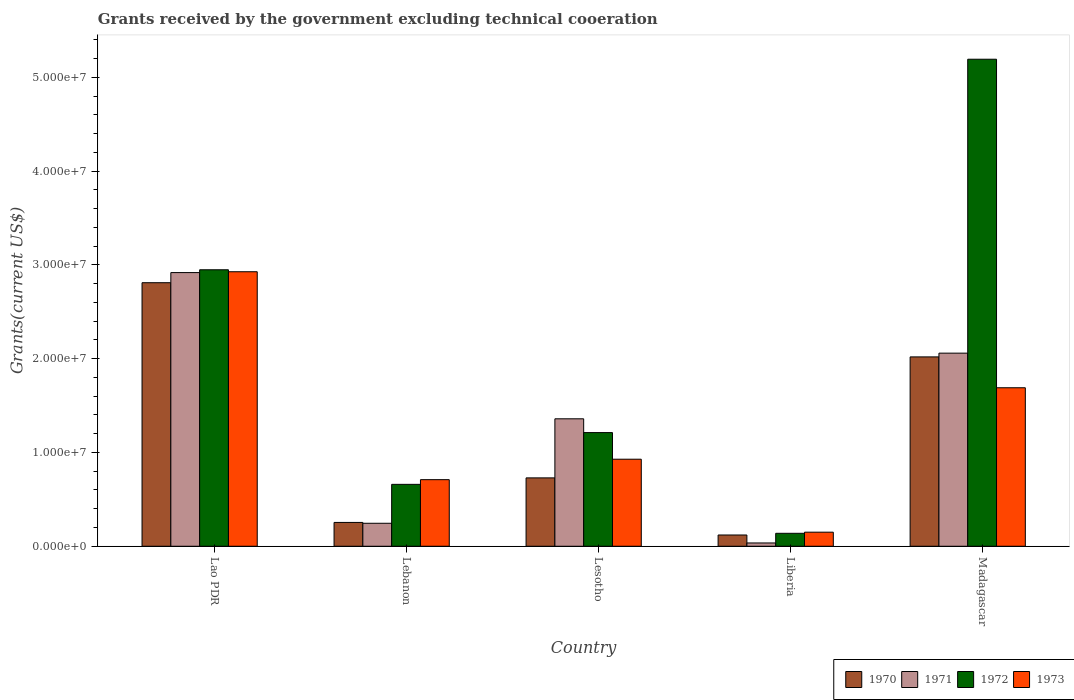How many groups of bars are there?
Give a very brief answer. 5. Are the number of bars per tick equal to the number of legend labels?
Your answer should be very brief. Yes. Are the number of bars on each tick of the X-axis equal?
Provide a short and direct response. Yes. How many bars are there on the 4th tick from the right?
Make the answer very short. 4. What is the label of the 3rd group of bars from the left?
Your answer should be very brief. Lesotho. In how many cases, is the number of bars for a given country not equal to the number of legend labels?
Offer a terse response. 0. What is the total grants received by the government in 1972 in Lebanon?
Your response must be concise. 6.60e+06. Across all countries, what is the maximum total grants received by the government in 1973?
Your answer should be very brief. 2.93e+07. Across all countries, what is the minimum total grants received by the government in 1970?
Provide a short and direct response. 1.20e+06. In which country was the total grants received by the government in 1970 maximum?
Keep it short and to the point. Lao PDR. In which country was the total grants received by the government in 1972 minimum?
Provide a succinct answer. Liberia. What is the total total grants received by the government in 1973 in the graph?
Provide a succinct answer. 6.40e+07. What is the difference between the total grants received by the government in 1973 in Lebanon and that in Liberia?
Offer a terse response. 5.60e+06. What is the difference between the total grants received by the government in 1973 in Lebanon and the total grants received by the government in 1970 in Lao PDR?
Offer a very short reply. -2.10e+07. What is the average total grants received by the government in 1971 per country?
Keep it short and to the point. 1.32e+07. What is the difference between the total grants received by the government of/in 1973 and total grants received by the government of/in 1972 in Madagascar?
Your answer should be very brief. -3.50e+07. What is the ratio of the total grants received by the government in 1973 in Lesotho to that in Madagascar?
Make the answer very short. 0.55. Is the total grants received by the government in 1972 in Lesotho less than that in Madagascar?
Your response must be concise. Yes. What is the difference between the highest and the second highest total grants received by the government in 1973?
Offer a terse response. 2.00e+07. What is the difference between the highest and the lowest total grants received by the government in 1971?
Offer a terse response. 2.88e+07. In how many countries, is the total grants received by the government in 1972 greater than the average total grants received by the government in 1972 taken over all countries?
Ensure brevity in your answer.  2. Is it the case that in every country, the sum of the total grants received by the government in 1973 and total grants received by the government in 1971 is greater than the sum of total grants received by the government in 1970 and total grants received by the government in 1972?
Make the answer very short. No. Is it the case that in every country, the sum of the total grants received by the government in 1970 and total grants received by the government in 1971 is greater than the total grants received by the government in 1972?
Provide a short and direct response. No. Are all the bars in the graph horizontal?
Your answer should be compact. No. What is the difference between two consecutive major ticks on the Y-axis?
Ensure brevity in your answer.  1.00e+07. Are the values on the major ticks of Y-axis written in scientific E-notation?
Make the answer very short. Yes. How many legend labels are there?
Give a very brief answer. 4. How are the legend labels stacked?
Provide a short and direct response. Horizontal. What is the title of the graph?
Offer a terse response. Grants received by the government excluding technical cooeration. What is the label or title of the X-axis?
Keep it short and to the point. Country. What is the label or title of the Y-axis?
Your answer should be compact. Grants(current US$). What is the Grants(current US$) of 1970 in Lao PDR?
Give a very brief answer. 2.81e+07. What is the Grants(current US$) in 1971 in Lao PDR?
Your answer should be compact. 2.92e+07. What is the Grants(current US$) in 1972 in Lao PDR?
Make the answer very short. 2.95e+07. What is the Grants(current US$) of 1973 in Lao PDR?
Ensure brevity in your answer.  2.93e+07. What is the Grants(current US$) in 1970 in Lebanon?
Provide a short and direct response. 2.54e+06. What is the Grants(current US$) in 1971 in Lebanon?
Make the answer very short. 2.45e+06. What is the Grants(current US$) in 1972 in Lebanon?
Your answer should be very brief. 6.60e+06. What is the Grants(current US$) in 1973 in Lebanon?
Offer a very short reply. 7.10e+06. What is the Grants(current US$) of 1970 in Lesotho?
Your response must be concise. 7.29e+06. What is the Grants(current US$) of 1971 in Lesotho?
Provide a short and direct response. 1.36e+07. What is the Grants(current US$) in 1972 in Lesotho?
Offer a very short reply. 1.21e+07. What is the Grants(current US$) in 1973 in Lesotho?
Make the answer very short. 9.28e+06. What is the Grants(current US$) of 1970 in Liberia?
Offer a very short reply. 1.20e+06. What is the Grants(current US$) of 1972 in Liberia?
Provide a succinct answer. 1.38e+06. What is the Grants(current US$) of 1973 in Liberia?
Offer a terse response. 1.50e+06. What is the Grants(current US$) in 1970 in Madagascar?
Provide a succinct answer. 2.02e+07. What is the Grants(current US$) in 1971 in Madagascar?
Offer a terse response. 2.06e+07. What is the Grants(current US$) of 1972 in Madagascar?
Your answer should be compact. 5.19e+07. What is the Grants(current US$) of 1973 in Madagascar?
Offer a very short reply. 1.69e+07. Across all countries, what is the maximum Grants(current US$) in 1970?
Provide a succinct answer. 2.81e+07. Across all countries, what is the maximum Grants(current US$) in 1971?
Your response must be concise. 2.92e+07. Across all countries, what is the maximum Grants(current US$) of 1972?
Provide a succinct answer. 5.19e+07. Across all countries, what is the maximum Grants(current US$) of 1973?
Ensure brevity in your answer.  2.93e+07. Across all countries, what is the minimum Grants(current US$) of 1970?
Your answer should be very brief. 1.20e+06. Across all countries, what is the minimum Grants(current US$) in 1971?
Give a very brief answer. 3.50e+05. Across all countries, what is the minimum Grants(current US$) of 1972?
Offer a very short reply. 1.38e+06. Across all countries, what is the minimum Grants(current US$) in 1973?
Your response must be concise. 1.50e+06. What is the total Grants(current US$) of 1970 in the graph?
Offer a very short reply. 5.93e+07. What is the total Grants(current US$) in 1971 in the graph?
Provide a succinct answer. 6.62e+07. What is the total Grants(current US$) of 1972 in the graph?
Keep it short and to the point. 1.02e+08. What is the total Grants(current US$) in 1973 in the graph?
Provide a short and direct response. 6.40e+07. What is the difference between the Grants(current US$) in 1970 in Lao PDR and that in Lebanon?
Provide a short and direct response. 2.56e+07. What is the difference between the Grants(current US$) in 1971 in Lao PDR and that in Lebanon?
Keep it short and to the point. 2.67e+07. What is the difference between the Grants(current US$) of 1972 in Lao PDR and that in Lebanon?
Make the answer very short. 2.29e+07. What is the difference between the Grants(current US$) of 1973 in Lao PDR and that in Lebanon?
Offer a very short reply. 2.22e+07. What is the difference between the Grants(current US$) of 1970 in Lao PDR and that in Lesotho?
Offer a terse response. 2.08e+07. What is the difference between the Grants(current US$) of 1971 in Lao PDR and that in Lesotho?
Keep it short and to the point. 1.56e+07. What is the difference between the Grants(current US$) in 1972 in Lao PDR and that in Lesotho?
Give a very brief answer. 1.74e+07. What is the difference between the Grants(current US$) in 1973 in Lao PDR and that in Lesotho?
Your answer should be very brief. 2.00e+07. What is the difference between the Grants(current US$) in 1970 in Lao PDR and that in Liberia?
Offer a terse response. 2.69e+07. What is the difference between the Grants(current US$) of 1971 in Lao PDR and that in Liberia?
Keep it short and to the point. 2.88e+07. What is the difference between the Grants(current US$) in 1972 in Lao PDR and that in Liberia?
Your answer should be very brief. 2.81e+07. What is the difference between the Grants(current US$) of 1973 in Lao PDR and that in Liberia?
Provide a short and direct response. 2.78e+07. What is the difference between the Grants(current US$) in 1970 in Lao PDR and that in Madagascar?
Provide a short and direct response. 7.91e+06. What is the difference between the Grants(current US$) in 1971 in Lao PDR and that in Madagascar?
Your answer should be very brief. 8.59e+06. What is the difference between the Grants(current US$) of 1972 in Lao PDR and that in Madagascar?
Ensure brevity in your answer.  -2.24e+07. What is the difference between the Grants(current US$) in 1973 in Lao PDR and that in Madagascar?
Offer a terse response. 1.24e+07. What is the difference between the Grants(current US$) of 1970 in Lebanon and that in Lesotho?
Your response must be concise. -4.75e+06. What is the difference between the Grants(current US$) of 1971 in Lebanon and that in Lesotho?
Your answer should be compact. -1.11e+07. What is the difference between the Grants(current US$) in 1972 in Lebanon and that in Lesotho?
Provide a succinct answer. -5.52e+06. What is the difference between the Grants(current US$) of 1973 in Lebanon and that in Lesotho?
Provide a short and direct response. -2.18e+06. What is the difference between the Grants(current US$) of 1970 in Lebanon and that in Liberia?
Keep it short and to the point. 1.34e+06. What is the difference between the Grants(current US$) in 1971 in Lebanon and that in Liberia?
Your response must be concise. 2.10e+06. What is the difference between the Grants(current US$) in 1972 in Lebanon and that in Liberia?
Your answer should be compact. 5.22e+06. What is the difference between the Grants(current US$) of 1973 in Lebanon and that in Liberia?
Your response must be concise. 5.60e+06. What is the difference between the Grants(current US$) of 1970 in Lebanon and that in Madagascar?
Offer a terse response. -1.76e+07. What is the difference between the Grants(current US$) of 1971 in Lebanon and that in Madagascar?
Give a very brief answer. -1.81e+07. What is the difference between the Grants(current US$) of 1972 in Lebanon and that in Madagascar?
Provide a short and direct response. -4.53e+07. What is the difference between the Grants(current US$) of 1973 in Lebanon and that in Madagascar?
Offer a very short reply. -9.80e+06. What is the difference between the Grants(current US$) in 1970 in Lesotho and that in Liberia?
Your response must be concise. 6.09e+06. What is the difference between the Grants(current US$) of 1971 in Lesotho and that in Liberia?
Ensure brevity in your answer.  1.32e+07. What is the difference between the Grants(current US$) of 1972 in Lesotho and that in Liberia?
Offer a terse response. 1.07e+07. What is the difference between the Grants(current US$) in 1973 in Lesotho and that in Liberia?
Make the answer very short. 7.78e+06. What is the difference between the Grants(current US$) of 1970 in Lesotho and that in Madagascar?
Make the answer very short. -1.29e+07. What is the difference between the Grants(current US$) in 1971 in Lesotho and that in Madagascar?
Your answer should be very brief. -7.00e+06. What is the difference between the Grants(current US$) in 1972 in Lesotho and that in Madagascar?
Your response must be concise. -3.98e+07. What is the difference between the Grants(current US$) of 1973 in Lesotho and that in Madagascar?
Your response must be concise. -7.62e+06. What is the difference between the Grants(current US$) in 1970 in Liberia and that in Madagascar?
Your response must be concise. -1.90e+07. What is the difference between the Grants(current US$) of 1971 in Liberia and that in Madagascar?
Provide a short and direct response. -2.02e+07. What is the difference between the Grants(current US$) in 1972 in Liberia and that in Madagascar?
Make the answer very short. -5.06e+07. What is the difference between the Grants(current US$) in 1973 in Liberia and that in Madagascar?
Your answer should be compact. -1.54e+07. What is the difference between the Grants(current US$) in 1970 in Lao PDR and the Grants(current US$) in 1971 in Lebanon?
Make the answer very short. 2.56e+07. What is the difference between the Grants(current US$) in 1970 in Lao PDR and the Grants(current US$) in 1972 in Lebanon?
Your response must be concise. 2.15e+07. What is the difference between the Grants(current US$) in 1970 in Lao PDR and the Grants(current US$) in 1973 in Lebanon?
Provide a short and direct response. 2.10e+07. What is the difference between the Grants(current US$) in 1971 in Lao PDR and the Grants(current US$) in 1972 in Lebanon?
Provide a succinct answer. 2.26e+07. What is the difference between the Grants(current US$) of 1971 in Lao PDR and the Grants(current US$) of 1973 in Lebanon?
Ensure brevity in your answer.  2.21e+07. What is the difference between the Grants(current US$) in 1972 in Lao PDR and the Grants(current US$) in 1973 in Lebanon?
Ensure brevity in your answer.  2.24e+07. What is the difference between the Grants(current US$) of 1970 in Lao PDR and the Grants(current US$) of 1971 in Lesotho?
Ensure brevity in your answer.  1.45e+07. What is the difference between the Grants(current US$) of 1970 in Lao PDR and the Grants(current US$) of 1972 in Lesotho?
Your answer should be compact. 1.60e+07. What is the difference between the Grants(current US$) in 1970 in Lao PDR and the Grants(current US$) in 1973 in Lesotho?
Keep it short and to the point. 1.88e+07. What is the difference between the Grants(current US$) of 1971 in Lao PDR and the Grants(current US$) of 1972 in Lesotho?
Make the answer very short. 1.71e+07. What is the difference between the Grants(current US$) in 1971 in Lao PDR and the Grants(current US$) in 1973 in Lesotho?
Provide a succinct answer. 1.99e+07. What is the difference between the Grants(current US$) in 1972 in Lao PDR and the Grants(current US$) in 1973 in Lesotho?
Your answer should be compact. 2.02e+07. What is the difference between the Grants(current US$) of 1970 in Lao PDR and the Grants(current US$) of 1971 in Liberia?
Your response must be concise. 2.78e+07. What is the difference between the Grants(current US$) in 1970 in Lao PDR and the Grants(current US$) in 1972 in Liberia?
Offer a terse response. 2.67e+07. What is the difference between the Grants(current US$) in 1970 in Lao PDR and the Grants(current US$) in 1973 in Liberia?
Your answer should be very brief. 2.66e+07. What is the difference between the Grants(current US$) in 1971 in Lao PDR and the Grants(current US$) in 1972 in Liberia?
Give a very brief answer. 2.78e+07. What is the difference between the Grants(current US$) of 1971 in Lao PDR and the Grants(current US$) of 1973 in Liberia?
Your answer should be compact. 2.77e+07. What is the difference between the Grants(current US$) in 1972 in Lao PDR and the Grants(current US$) in 1973 in Liberia?
Offer a very short reply. 2.80e+07. What is the difference between the Grants(current US$) of 1970 in Lao PDR and the Grants(current US$) of 1971 in Madagascar?
Ensure brevity in your answer.  7.51e+06. What is the difference between the Grants(current US$) in 1970 in Lao PDR and the Grants(current US$) in 1972 in Madagascar?
Make the answer very short. -2.38e+07. What is the difference between the Grants(current US$) in 1970 in Lao PDR and the Grants(current US$) in 1973 in Madagascar?
Offer a terse response. 1.12e+07. What is the difference between the Grants(current US$) in 1971 in Lao PDR and the Grants(current US$) in 1972 in Madagascar?
Offer a terse response. -2.28e+07. What is the difference between the Grants(current US$) in 1971 in Lao PDR and the Grants(current US$) in 1973 in Madagascar?
Your answer should be compact. 1.23e+07. What is the difference between the Grants(current US$) of 1972 in Lao PDR and the Grants(current US$) of 1973 in Madagascar?
Your answer should be very brief. 1.26e+07. What is the difference between the Grants(current US$) of 1970 in Lebanon and the Grants(current US$) of 1971 in Lesotho?
Make the answer very short. -1.10e+07. What is the difference between the Grants(current US$) of 1970 in Lebanon and the Grants(current US$) of 1972 in Lesotho?
Offer a very short reply. -9.58e+06. What is the difference between the Grants(current US$) of 1970 in Lebanon and the Grants(current US$) of 1973 in Lesotho?
Provide a succinct answer. -6.74e+06. What is the difference between the Grants(current US$) of 1971 in Lebanon and the Grants(current US$) of 1972 in Lesotho?
Make the answer very short. -9.67e+06. What is the difference between the Grants(current US$) of 1971 in Lebanon and the Grants(current US$) of 1973 in Lesotho?
Keep it short and to the point. -6.83e+06. What is the difference between the Grants(current US$) in 1972 in Lebanon and the Grants(current US$) in 1973 in Lesotho?
Make the answer very short. -2.68e+06. What is the difference between the Grants(current US$) of 1970 in Lebanon and the Grants(current US$) of 1971 in Liberia?
Give a very brief answer. 2.19e+06. What is the difference between the Grants(current US$) of 1970 in Lebanon and the Grants(current US$) of 1972 in Liberia?
Make the answer very short. 1.16e+06. What is the difference between the Grants(current US$) in 1970 in Lebanon and the Grants(current US$) in 1973 in Liberia?
Offer a very short reply. 1.04e+06. What is the difference between the Grants(current US$) in 1971 in Lebanon and the Grants(current US$) in 1972 in Liberia?
Provide a short and direct response. 1.07e+06. What is the difference between the Grants(current US$) of 1971 in Lebanon and the Grants(current US$) of 1973 in Liberia?
Offer a terse response. 9.50e+05. What is the difference between the Grants(current US$) of 1972 in Lebanon and the Grants(current US$) of 1973 in Liberia?
Keep it short and to the point. 5.10e+06. What is the difference between the Grants(current US$) in 1970 in Lebanon and the Grants(current US$) in 1971 in Madagascar?
Offer a terse response. -1.80e+07. What is the difference between the Grants(current US$) in 1970 in Lebanon and the Grants(current US$) in 1972 in Madagascar?
Provide a succinct answer. -4.94e+07. What is the difference between the Grants(current US$) of 1970 in Lebanon and the Grants(current US$) of 1973 in Madagascar?
Your response must be concise. -1.44e+07. What is the difference between the Grants(current US$) in 1971 in Lebanon and the Grants(current US$) in 1972 in Madagascar?
Your response must be concise. -4.95e+07. What is the difference between the Grants(current US$) of 1971 in Lebanon and the Grants(current US$) of 1973 in Madagascar?
Offer a terse response. -1.44e+07. What is the difference between the Grants(current US$) in 1972 in Lebanon and the Grants(current US$) in 1973 in Madagascar?
Keep it short and to the point. -1.03e+07. What is the difference between the Grants(current US$) in 1970 in Lesotho and the Grants(current US$) in 1971 in Liberia?
Provide a short and direct response. 6.94e+06. What is the difference between the Grants(current US$) of 1970 in Lesotho and the Grants(current US$) of 1972 in Liberia?
Give a very brief answer. 5.91e+06. What is the difference between the Grants(current US$) in 1970 in Lesotho and the Grants(current US$) in 1973 in Liberia?
Make the answer very short. 5.79e+06. What is the difference between the Grants(current US$) in 1971 in Lesotho and the Grants(current US$) in 1972 in Liberia?
Offer a very short reply. 1.22e+07. What is the difference between the Grants(current US$) in 1971 in Lesotho and the Grants(current US$) in 1973 in Liberia?
Your answer should be compact. 1.21e+07. What is the difference between the Grants(current US$) of 1972 in Lesotho and the Grants(current US$) of 1973 in Liberia?
Offer a very short reply. 1.06e+07. What is the difference between the Grants(current US$) of 1970 in Lesotho and the Grants(current US$) of 1971 in Madagascar?
Your response must be concise. -1.33e+07. What is the difference between the Grants(current US$) of 1970 in Lesotho and the Grants(current US$) of 1972 in Madagascar?
Your response must be concise. -4.46e+07. What is the difference between the Grants(current US$) of 1970 in Lesotho and the Grants(current US$) of 1973 in Madagascar?
Give a very brief answer. -9.61e+06. What is the difference between the Grants(current US$) of 1971 in Lesotho and the Grants(current US$) of 1972 in Madagascar?
Your response must be concise. -3.83e+07. What is the difference between the Grants(current US$) in 1971 in Lesotho and the Grants(current US$) in 1973 in Madagascar?
Give a very brief answer. -3.31e+06. What is the difference between the Grants(current US$) of 1972 in Lesotho and the Grants(current US$) of 1973 in Madagascar?
Make the answer very short. -4.78e+06. What is the difference between the Grants(current US$) in 1970 in Liberia and the Grants(current US$) in 1971 in Madagascar?
Your response must be concise. -1.94e+07. What is the difference between the Grants(current US$) of 1970 in Liberia and the Grants(current US$) of 1972 in Madagascar?
Your response must be concise. -5.07e+07. What is the difference between the Grants(current US$) of 1970 in Liberia and the Grants(current US$) of 1973 in Madagascar?
Ensure brevity in your answer.  -1.57e+07. What is the difference between the Grants(current US$) in 1971 in Liberia and the Grants(current US$) in 1972 in Madagascar?
Provide a short and direct response. -5.16e+07. What is the difference between the Grants(current US$) in 1971 in Liberia and the Grants(current US$) in 1973 in Madagascar?
Your answer should be compact. -1.66e+07. What is the difference between the Grants(current US$) in 1972 in Liberia and the Grants(current US$) in 1973 in Madagascar?
Make the answer very short. -1.55e+07. What is the average Grants(current US$) of 1970 per country?
Make the answer very short. 1.19e+07. What is the average Grants(current US$) in 1971 per country?
Offer a very short reply. 1.32e+07. What is the average Grants(current US$) in 1972 per country?
Provide a short and direct response. 2.03e+07. What is the average Grants(current US$) in 1973 per country?
Your answer should be compact. 1.28e+07. What is the difference between the Grants(current US$) of 1970 and Grants(current US$) of 1971 in Lao PDR?
Your response must be concise. -1.08e+06. What is the difference between the Grants(current US$) in 1970 and Grants(current US$) in 1972 in Lao PDR?
Provide a succinct answer. -1.38e+06. What is the difference between the Grants(current US$) of 1970 and Grants(current US$) of 1973 in Lao PDR?
Provide a short and direct response. -1.17e+06. What is the difference between the Grants(current US$) of 1972 and Grants(current US$) of 1973 in Lao PDR?
Offer a very short reply. 2.10e+05. What is the difference between the Grants(current US$) of 1970 and Grants(current US$) of 1972 in Lebanon?
Offer a terse response. -4.06e+06. What is the difference between the Grants(current US$) of 1970 and Grants(current US$) of 1973 in Lebanon?
Provide a short and direct response. -4.56e+06. What is the difference between the Grants(current US$) in 1971 and Grants(current US$) in 1972 in Lebanon?
Give a very brief answer. -4.15e+06. What is the difference between the Grants(current US$) in 1971 and Grants(current US$) in 1973 in Lebanon?
Your answer should be compact. -4.65e+06. What is the difference between the Grants(current US$) in 1972 and Grants(current US$) in 1973 in Lebanon?
Offer a terse response. -5.00e+05. What is the difference between the Grants(current US$) in 1970 and Grants(current US$) in 1971 in Lesotho?
Your answer should be compact. -6.30e+06. What is the difference between the Grants(current US$) in 1970 and Grants(current US$) in 1972 in Lesotho?
Give a very brief answer. -4.83e+06. What is the difference between the Grants(current US$) of 1970 and Grants(current US$) of 1973 in Lesotho?
Your answer should be very brief. -1.99e+06. What is the difference between the Grants(current US$) of 1971 and Grants(current US$) of 1972 in Lesotho?
Make the answer very short. 1.47e+06. What is the difference between the Grants(current US$) of 1971 and Grants(current US$) of 1973 in Lesotho?
Give a very brief answer. 4.31e+06. What is the difference between the Grants(current US$) of 1972 and Grants(current US$) of 1973 in Lesotho?
Ensure brevity in your answer.  2.84e+06. What is the difference between the Grants(current US$) in 1970 and Grants(current US$) in 1971 in Liberia?
Give a very brief answer. 8.50e+05. What is the difference between the Grants(current US$) of 1970 and Grants(current US$) of 1972 in Liberia?
Your answer should be compact. -1.80e+05. What is the difference between the Grants(current US$) in 1970 and Grants(current US$) in 1973 in Liberia?
Your answer should be very brief. -3.00e+05. What is the difference between the Grants(current US$) in 1971 and Grants(current US$) in 1972 in Liberia?
Offer a very short reply. -1.03e+06. What is the difference between the Grants(current US$) of 1971 and Grants(current US$) of 1973 in Liberia?
Ensure brevity in your answer.  -1.15e+06. What is the difference between the Grants(current US$) in 1970 and Grants(current US$) in 1971 in Madagascar?
Keep it short and to the point. -4.00e+05. What is the difference between the Grants(current US$) in 1970 and Grants(current US$) in 1972 in Madagascar?
Your answer should be very brief. -3.17e+07. What is the difference between the Grants(current US$) in 1970 and Grants(current US$) in 1973 in Madagascar?
Offer a very short reply. 3.29e+06. What is the difference between the Grants(current US$) in 1971 and Grants(current US$) in 1972 in Madagascar?
Your answer should be very brief. -3.13e+07. What is the difference between the Grants(current US$) of 1971 and Grants(current US$) of 1973 in Madagascar?
Provide a succinct answer. 3.69e+06. What is the difference between the Grants(current US$) in 1972 and Grants(current US$) in 1973 in Madagascar?
Your answer should be very brief. 3.50e+07. What is the ratio of the Grants(current US$) of 1970 in Lao PDR to that in Lebanon?
Ensure brevity in your answer.  11.06. What is the ratio of the Grants(current US$) of 1971 in Lao PDR to that in Lebanon?
Offer a terse response. 11.91. What is the ratio of the Grants(current US$) of 1972 in Lao PDR to that in Lebanon?
Your answer should be compact. 4.47. What is the ratio of the Grants(current US$) in 1973 in Lao PDR to that in Lebanon?
Your response must be concise. 4.12. What is the ratio of the Grants(current US$) in 1970 in Lao PDR to that in Lesotho?
Your response must be concise. 3.85. What is the ratio of the Grants(current US$) in 1971 in Lao PDR to that in Lesotho?
Keep it short and to the point. 2.15. What is the ratio of the Grants(current US$) in 1972 in Lao PDR to that in Lesotho?
Ensure brevity in your answer.  2.43. What is the ratio of the Grants(current US$) in 1973 in Lao PDR to that in Lesotho?
Offer a very short reply. 3.15. What is the ratio of the Grants(current US$) in 1970 in Lao PDR to that in Liberia?
Your response must be concise. 23.42. What is the ratio of the Grants(current US$) of 1971 in Lao PDR to that in Liberia?
Make the answer very short. 83.37. What is the ratio of the Grants(current US$) in 1972 in Lao PDR to that in Liberia?
Your response must be concise. 21.36. What is the ratio of the Grants(current US$) in 1973 in Lao PDR to that in Liberia?
Your answer should be compact. 19.51. What is the ratio of the Grants(current US$) in 1970 in Lao PDR to that in Madagascar?
Keep it short and to the point. 1.39. What is the ratio of the Grants(current US$) of 1971 in Lao PDR to that in Madagascar?
Keep it short and to the point. 1.42. What is the ratio of the Grants(current US$) of 1972 in Lao PDR to that in Madagascar?
Provide a short and direct response. 0.57. What is the ratio of the Grants(current US$) in 1973 in Lao PDR to that in Madagascar?
Provide a short and direct response. 1.73. What is the ratio of the Grants(current US$) of 1970 in Lebanon to that in Lesotho?
Your response must be concise. 0.35. What is the ratio of the Grants(current US$) in 1971 in Lebanon to that in Lesotho?
Your response must be concise. 0.18. What is the ratio of the Grants(current US$) in 1972 in Lebanon to that in Lesotho?
Keep it short and to the point. 0.54. What is the ratio of the Grants(current US$) of 1973 in Lebanon to that in Lesotho?
Give a very brief answer. 0.77. What is the ratio of the Grants(current US$) of 1970 in Lebanon to that in Liberia?
Your answer should be very brief. 2.12. What is the ratio of the Grants(current US$) in 1971 in Lebanon to that in Liberia?
Your response must be concise. 7. What is the ratio of the Grants(current US$) of 1972 in Lebanon to that in Liberia?
Your answer should be compact. 4.78. What is the ratio of the Grants(current US$) of 1973 in Lebanon to that in Liberia?
Offer a terse response. 4.73. What is the ratio of the Grants(current US$) of 1970 in Lebanon to that in Madagascar?
Make the answer very short. 0.13. What is the ratio of the Grants(current US$) in 1971 in Lebanon to that in Madagascar?
Ensure brevity in your answer.  0.12. What is the ratio of the Grants(current US$) of 1972 in Lebanon to that in Madagascar?
Offer a very short reply. 0.13. What is the ratio of the Grants(current US$) in 1973 in Lebanon to that in Madagascar?
Keep it short and to the point. 0.42. What is the ratio of the Grants(current US$) of 1970 in Lesotho to that in Liberia?
Offer a very short reply. 6.08. What is the ratio of the Grants(current US$) in 1971 in Lesotho to that in Liberia?
Provide a short and direct response. 38.83. What is the ratio of the Grants(current US$) in 1972 in Lesotho to that in Liberia?
Your answer should be compact. 8.78. What is the ratio of the Grants(current US$) in 1973 in Lesotho to that in Liberia?
Make the answer very short. 6.19. What is the ratio of the Grants(current US$) in 1970 in Lesotho to that in Madagascar?
Offer a terse response. 0.36. What is the ratio of the Grants(current US$) of 1971 in Lesotho to that in Madagascar?
Ensure brevity in your answer.  0.66. What is the ratio of the Grants(current US$) in 1972 in Lesotho to that in Madagascar?
Ensure brevity in your answer.  0.23. What is the ratio of the Grants(current US$) of 1973 in Lesotho to that in Madagascar?
Your answer should be compact. 0.55. What is the ratio of the Grants(current US$) of 1970 in Liberia to that in Madagascar?
Offer a terse response. 0.06. What is the ratio of the Grants(current US$) of 1971 in Liberia to that in Madagascar?
Give a very brief answer. 0.02. What is the ratio of the Grants(current US$) of 1972 in Liberia to that in Madagascar?
Offer a very short reply. 0.03. What is the ratio of the Grants(current US$) in 1973 in Liberia to that in Madagascar?
Offer a very short reply. 0.09. What is the difference between the highest and the second highest Grants(current US$) in 1970?
Your response must be concise. 7.91e+06. What is the difference between the highest and the second highest Grants(current US$) in 1971?
Give a very brief answer. 8.59e+06. What is the difference between the highest and the second highest Grants(current US$) in 1972?
Provide a succinct answer. 2.24e+07. What is the difference between the highest and the second highest Grants(current US$) in 1973?
Your answer should be very brief. 1.24e+07. What is the difference between the highest and the lowest Grants(current US$) in 1970?
Offer a terse response. 2.69e+07. What is the difference between the highest and the lowest Grants(current US$) in 1971?
Provide a short and direct response. 2.88e+07. What is the difference between the highest and the lowest Grants(current US$) in 1972?
Make the answer very short. 5.06e+07. What is the difference between the highest and the lowest Grants(current US$) in 1973?
Ensure brevity in your answer.  2.78e+07. 